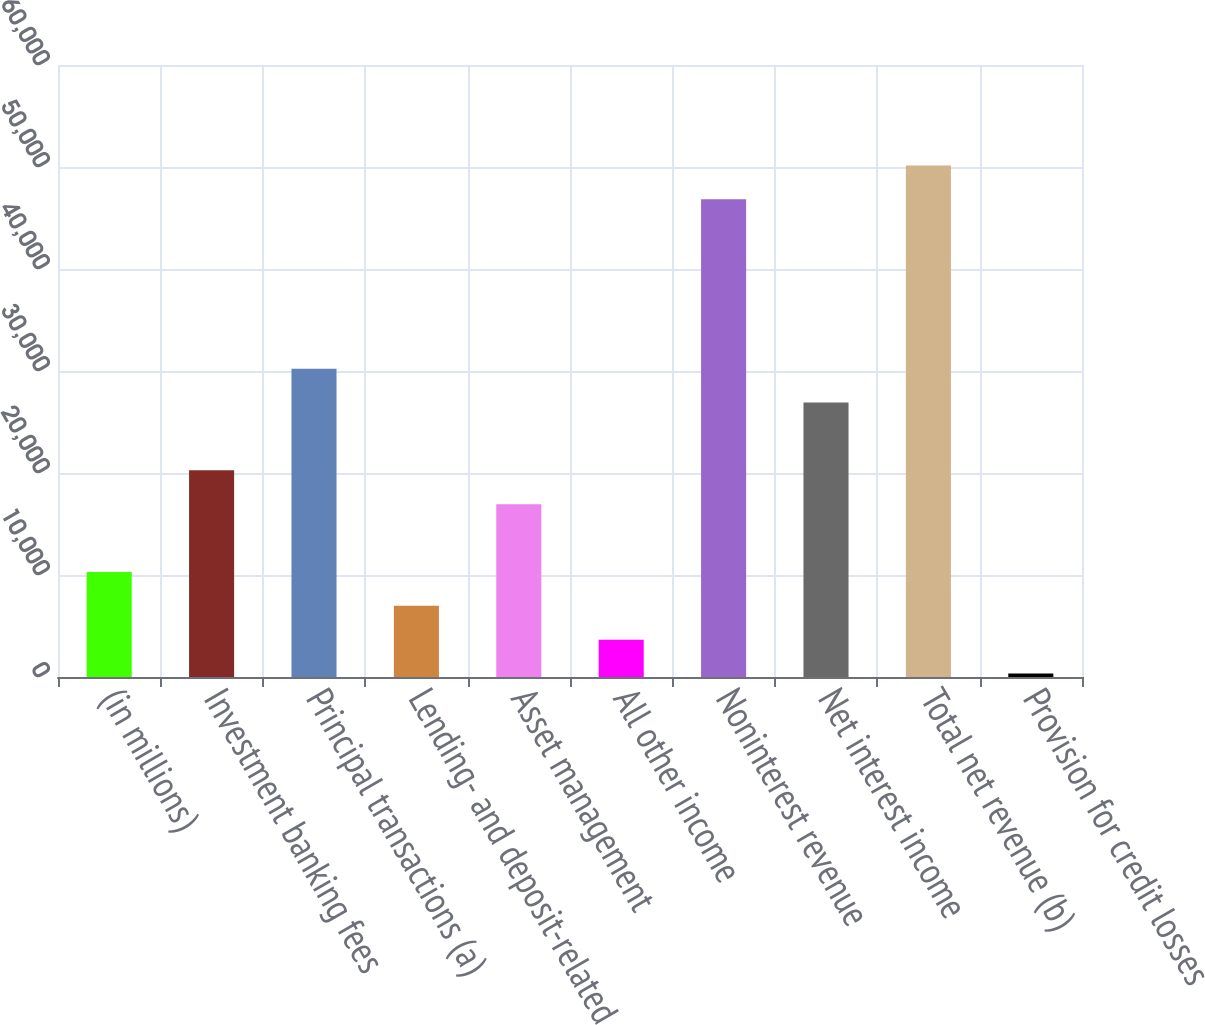Convert chart to OTSL. <chart><loc_0><loc_0><loc_500><loc_500><bar_chart><fcel>(in millions)<fcel>Investment banking fees<fcel>Principal transactions (a)<fcel>Lending- and deposit-related<fcel>Asset management<fcel>All other income<fcel>Noninterest revenue<fcel>Net interest income<fcel>Total net revenue (b)<fcel>Provision for credit losses<nl><fcel>10295<fcel>20258<fcel>30221<fcel>6974<fcel>16937<fcel>3653<fcel>46826<fcel>26900<fcel>50147<fcel>332<nl></chart> 